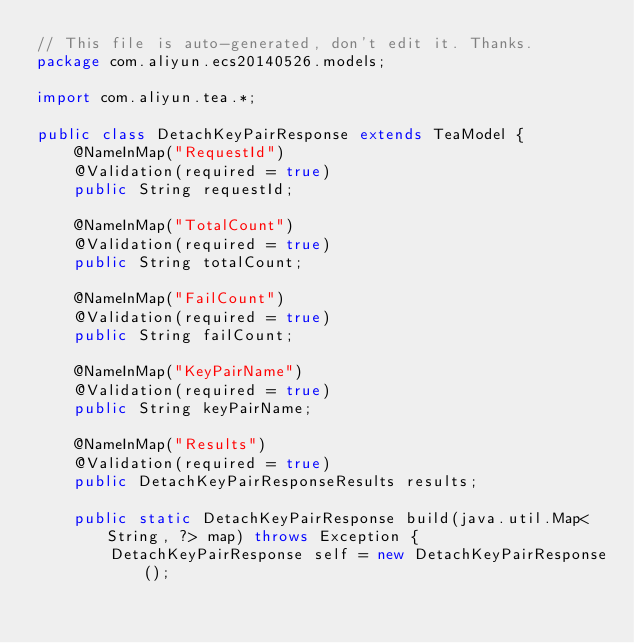Convert code to text. <code><loc_0><loc_0><loc_500><loc_500><_Java_>// This file is auto-generated, don't edit it. Thanks.
package com.aliyun.ecs20140526.models;

import com.aliyun.tea.*;

public class DetachKeyPairResponse extends TeaModel {
    @NameInMap("RequestId")
    @Validation(required = true)
    public String requestId;

    @NameInMap("TotalCount")
    @Validation(required = true)
    public String totalCount;

    @NameInMap("FailCount")
    @Validation(required = true)
    public String failCount;

    @NameInMap("KeyPairName")
    @Validation(required = true)
    public String keyPairName;

    @NameInMap("Results")
    @Validation(required = true)
    public DetachKeyPairResponseResults results;

    public static DetachKeyPairResponse build(java.util.Map<String, ?> map) throws Exception {
        DetachKeyPairResponse self = new DetachKeyPairResponse();</code> 